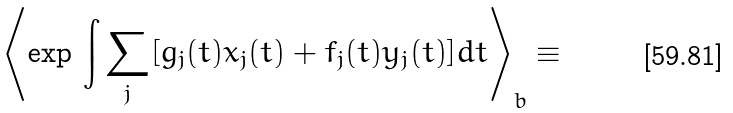Convert formula to latex. <formula><loc_0><loc_0><loc_500><loc_500>\left \langle \exp \, \int \sum _ { j } [ g _ { j } ( t ) x _ { j } ( t ) + f _ { j } ( t ) y _ { j } ( t ) ] d t \right \rangle _ { b } \equiv</formula> 